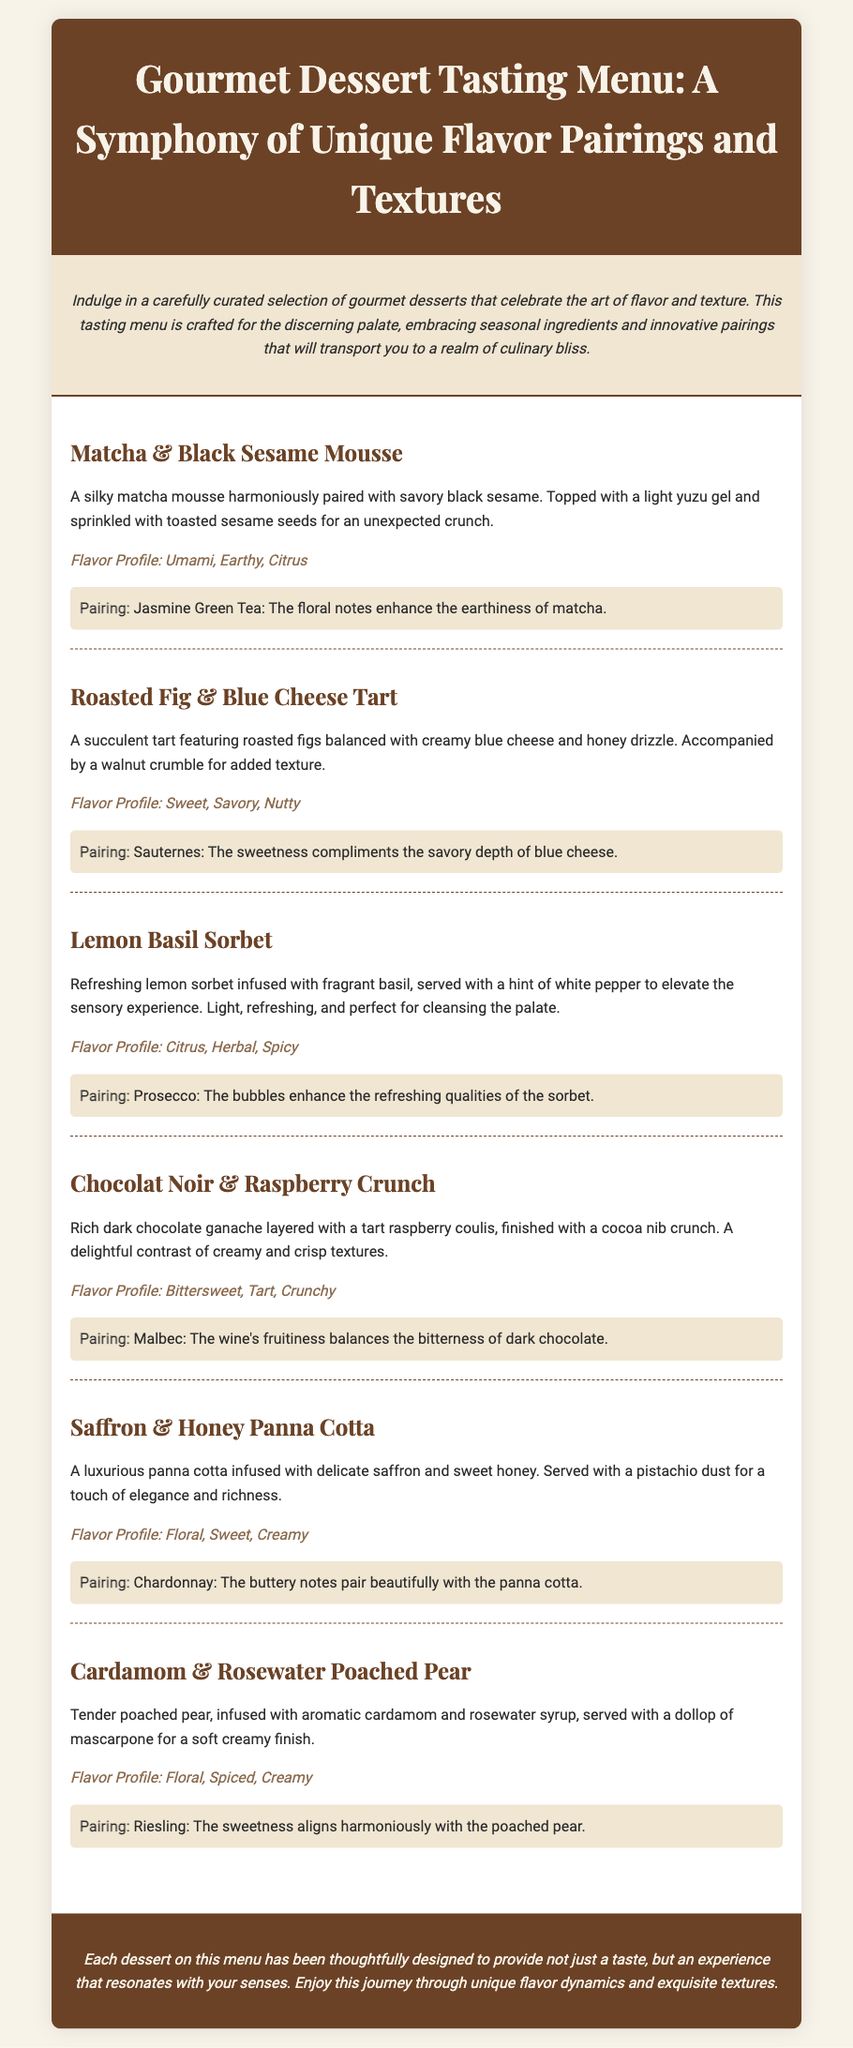What is the first dessert on the menu? The first dessert listed in the document is "Matcha & Black Sesame Mousse".
Answer: Matcha & Black Sesame Mousse What flavor profile describes the Lemon Basil Sorbet? The Lemon Basil Sorbet has the flavor profile: Citrus, Herbal, Spicy.
Answer: Citrus, Herbal, Spicy What dessert includes blue cheese? The dessert that includes blue cheese is "Roasted Fig & Blue Cheese Tart".
Answer: Roasted Fig & Blue Cheese Tart What beverage is paired with the Chocolat Noir & Raspberry Crunch? The beverage paired with the Chocolat Noir & Raspberry Crunch is Malbec.
Answer: Malbec What is a unique ingredient in the Saffron & Honey Panna Cotta? A unique ingredient in the Saffron & Honey Panna Cotta is saffron.
Answer: Saffron Which dessert features a walnut crumble? The dessert that features a walnut crumble is "Roasted Fig & Blue Cheese Tart".
Answer: Roasted Fig & Blue Cheese Tart How many courses are listed in the tasting menu? There are six courses listed in the tasting menu.
Answer: Six What is the last dessert mentioned in the menu? The last dessert mentioned in the menu is "Cardamom & Rosewater Poached Pear".
Answer: Cardamom & Rosewater Poached Pear What text color is used for the dessert titles? The text color used for the dessert titles is #6b4226.
Answer: #6b4226 